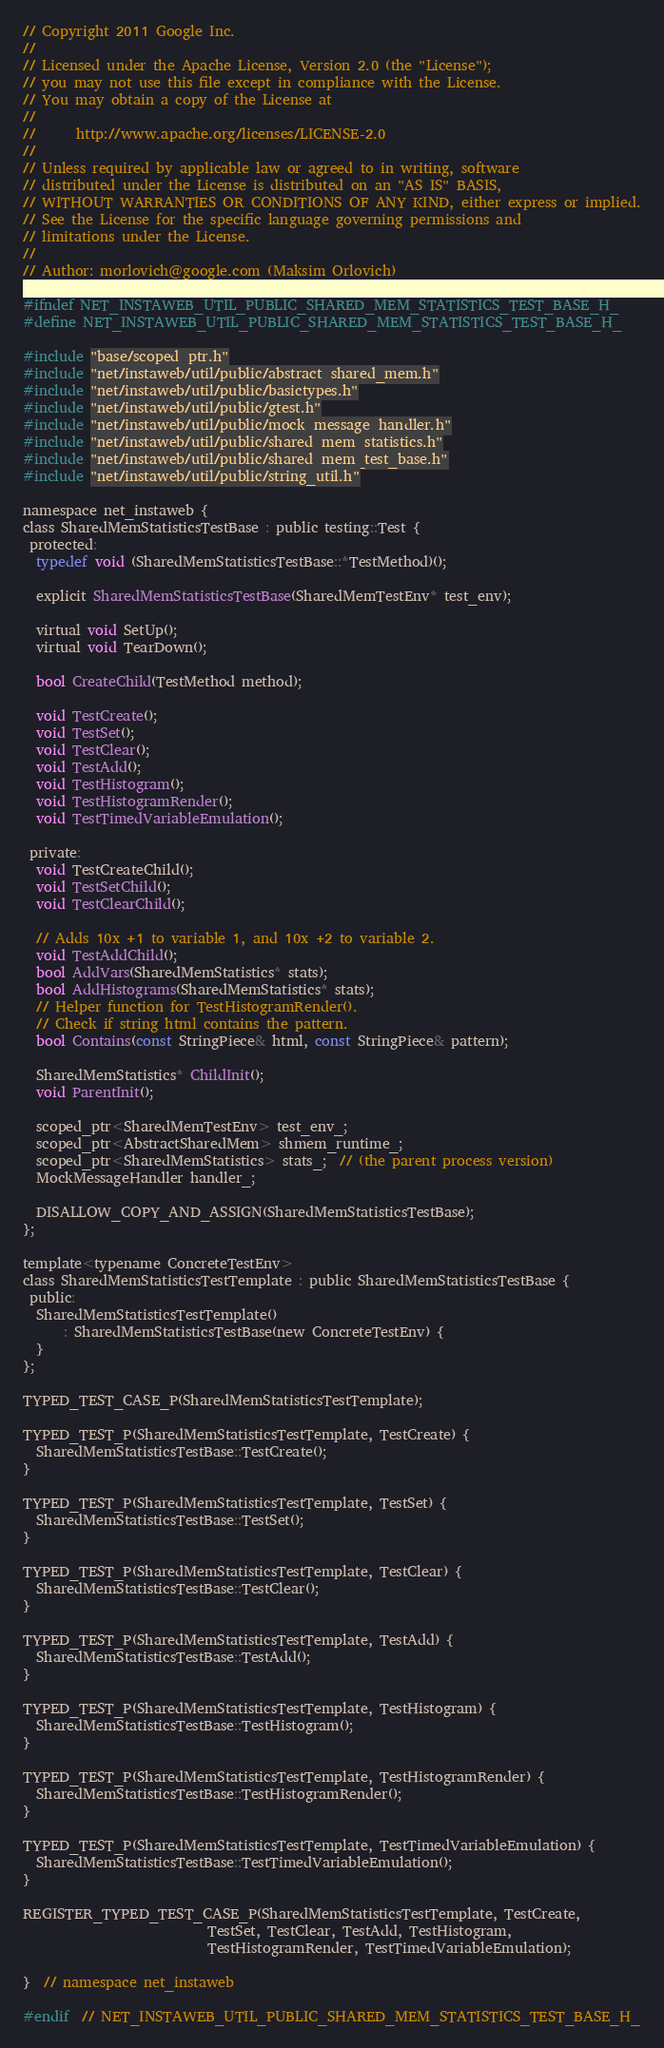Convert code to text. <code><loc_0><loc_0><loc_500><loc_500><_C_>// Copyright 2011 Google Inc.
//
// Licensed under the Apache License, Version 2.0 (the "License");
// you may not use this file except in compliance with the License.
// You may obtain a copy of the License at
//
//      http://www.apache.org/licenses/LICENSE-2.0
//
// Unless required by applicable law or agreed to in writing, software
// distributed under the License is distributed on an "AS IS" BASIS,
// WITHOUT WARRANTIES OR CONDITIONS OF ANY KIND, either express or implied.
// See the License for the specific language governing permissions and
// limitations under the License.
//
// Author: morlovich@google.com (Maksim Orlovich)

#ifndef NET_INSTAWEB_UTIL_PUBLIC_SHARED_MEM_STATISTICS_TEST_BASE_H_
#define NET_INSTAWEB_UTIL_PUBLIC_SHARED_MEM_STATISTICS_TEST_BASE_H_

#include "base/scoped_ptr.h"
#include "net/instaweb/util/public/abstract_shared_mem.h"
#include "net/instaweb/util/public/basictypes.h"
#include "net/instaweb/util/public/gtest.h"
#include "net/instaweb/util/public/mock_message_handler.h"
#include "net/instaweb/util/public/shared_mem_statistics.h"
#include "net/instaweb/util/public/shared_mem_test_base.h"
#include "net/instaweb/util/public/string_util.h"

namespace net_instaweb {
class SharedMemStatisticsTestBase : public testing::Test {
 protected:
  typedef void (SharedMemStatisticsTestBase::*TestMethod)();

  explicit SharedMemStatisticsTestBase(SharedMemTestEnv* test_env);

  virtual void SetUp();
  virtual void TearDown();

  bool CreateChild(TestMethod method);

  void TestCreate();
  void TestSet();
  void TestClear();
  void TestAdd();
  void TestHistogram();
  void TestHistogramRender();
  void TestTimedVariableEmulation();

 private:
  void TestCreateChild();
  void TestSetChild();
  void TestClearChild();

  // Adds 10x +1 to variable 1, and 10x +2 to variable 2.
  void TestAddChild();
  bool AddVars(SharedMemStatistics* stats);
  bool AddHistograms(SharedMemStatistics* stats);
  // Helper function for TestHistogramRender().
  // Check if string html contains the pattern.
  bool Contains(const StringPiece& html, const StringPiece& pattern);

  SharedMemStatistics* ChildInit();
  void ParentInit();

  scoped_ptr<SharedMemTestEnv> test_env_;
  scoped_ptr<AbstractSharedMem> shmem_runtime_;
  scoped_ptr<SharedMemStatistics> stats_;  // (the parent process version)
  MockMessageHandler handler_;

  DISALLOW_COPY_AND_ASSIGN(SharedMemStatisticsTestBase);
};

template<typename ConcreteTestEnv>
class SharedMemStatisticsTestTemplate : public SharedMemStatisticsTestBase {
 public:
  SharedMemStatisticsTestTemplate()
      : SharedMemStatisticsTestBase(new ConcreteTestEnv) {
  }
};

TYPED_TEST_CASE_P(SharedMemStatisticsTestTemplate);

TYPED_TEST_P(SharedMemStatisticsTestTemplate, TestCreate) {
  SharedMemStatisticsTestBase::TestCreate();
}

TYPED_TEST_P(SharedMemStatisticsTestTemplate, TestSet) {
  SharedMemStatisticsTestBase::TestSet();
}

TYPED_TEST_P(SharedMemStatisticsTestTemplate, TestClear) {
  SharedMemStatisticsTestBase::TestClear();
}

TYPED_TEST_P(SharedMemStatisticsTestTemplate, TestAdd) {
  SharedMemStatisticsTestBase::TestAdd();
}

TYPED_TEST_P(SharedMemStatisticsTestTemplate, TestHistogram) {
  SharedMemStatisticsTestBase::TestHistogram();
}

TYPED_TEST_P(SharedMemStatisticsTestTemplate, TestHistogramRender) {
  SharedMemStatisticsTestBase::TestHistogramRender();
}

TYPED_TEST_P(SharedMemStatisticsTestTemplate, TestTimedVariableEmulation) {
  SharedMemStatisticsTestBase::TestTimedVariableEmulation();
}

REGISTER_TYPED_TEST_CASE_P(SharedMemStatisticsTestTemplate, TestCreate,
                           TestSet, TestClear, TestAdd, TestHistogram,
                           TestHistogramRender, TestTimedVariableEmulation);

}  // namespace net_instaweb

#endif  // NET_INSTAWEB_UTIL_PUBLIC_SHARED_MEM_STATISTICS_TEST_BASE_H_
</code> 